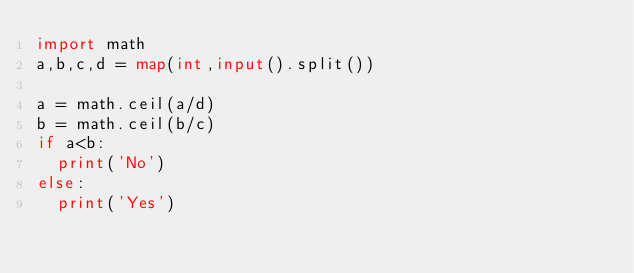Convert code to text. <code><loc_0><loc_0><loc_500><loc_500><_Python_>import math
a,b,c,d = map(int,input().split())

a = math.ceil(a/d)
b = math.ceil(b/c)
if a<b:
  print('No')
else:
  print('Yes')

</code> 